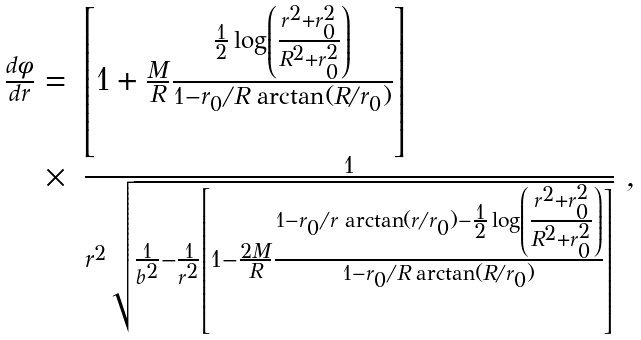<formula> <loc_0><loc_0><loc_500><loc_500>\begin{array} { r l } { { \frac { d \phi } { d r } = } } & { { \left [ 1 + \frac { M } { R } \frac { \frac { 1 } { 2 } \log \left ( \frac { r ^ { 2 } + r _ { 0 } ^ { 2 } } { R ^ { 2 } + r _ { 0 } ^ { 2 } } \right ) } { 1 - r _ { 0 } / R \, \arctan ( R / r _ { 0 } ) } \right ] } } \\ { \times } & { { \frac { 1 } { r ^ { 2 } \sqrt { \frac { 1 } { b ^ { 2 } } - \frac { 1 } { r ^ { 2 } } \left [ 1 - \frac { 2 M } { R } \frac { 1 - r _ { 0 } / r \, \arctan ( r / r _ { 0 } ) - \frac { 1 } { 2 } \log \left ( \frac { r ^ { 2 } + r _ { 0 } ^ { 2 } } { R ^ { 2 } + r _ { 0 } ^ { 2 } } \right ) } { 1 - r _ { 0 } / R \, \arctan ( R / r _ { 0 } ) } \right ] } } \ , } } \end{array}</formula> 